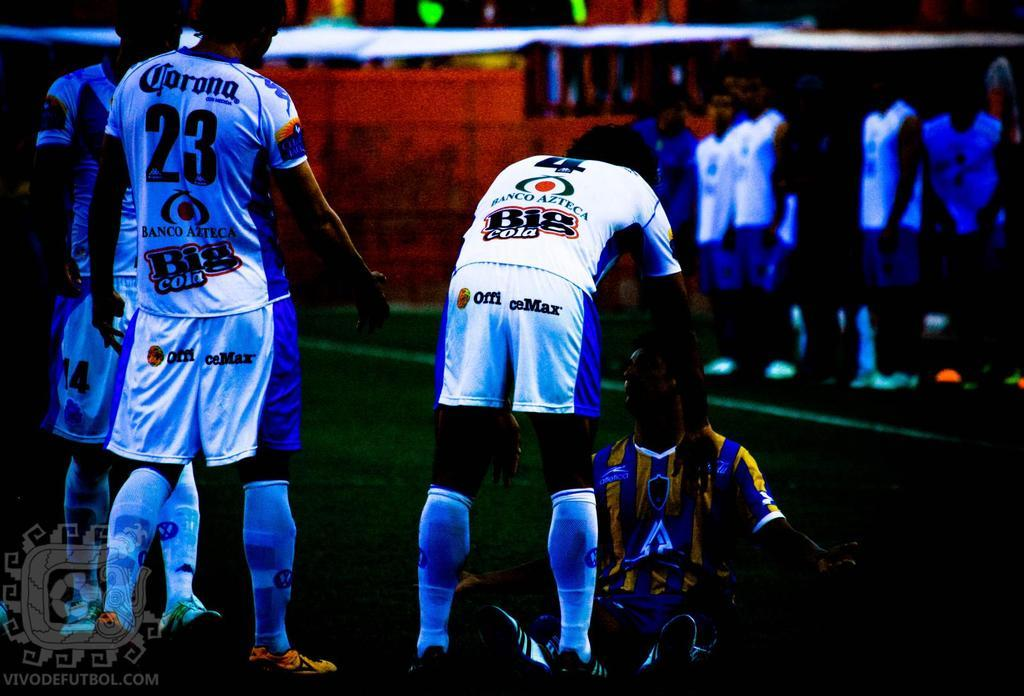<image>
Summarize the visual content of the image. A Big Cola logo is on the back of a man's shirt. 